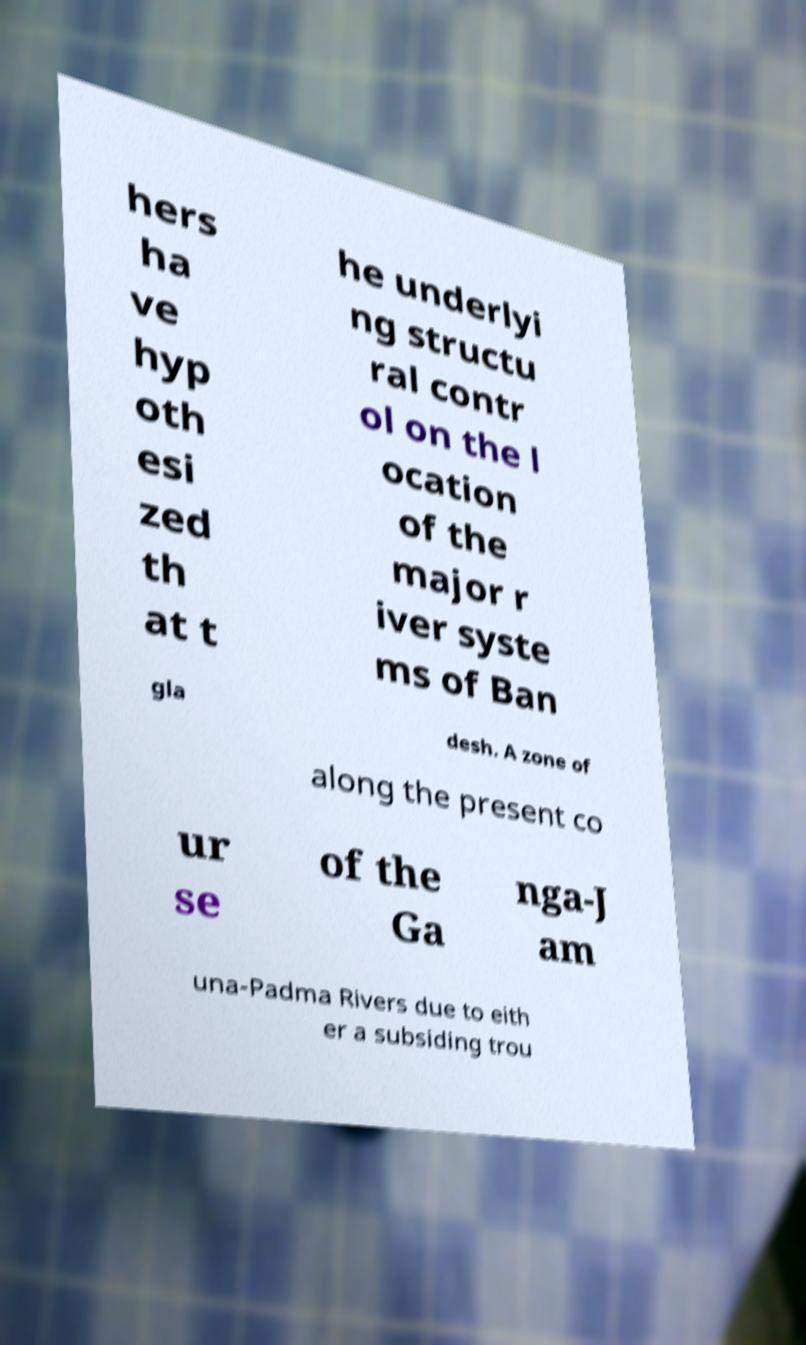For documentation purposes, I need the text within this image transcribed. Could you provide that? hers ha ve hyp oth esi zed th at t he underlyi ng structu ral contr ol on the l ocation of the major r iver syste ms of Ban gla desh. A zone of along the present co ur se of the Ga nga-J am una-Padma Rivers due to eith er a subsiding trou 